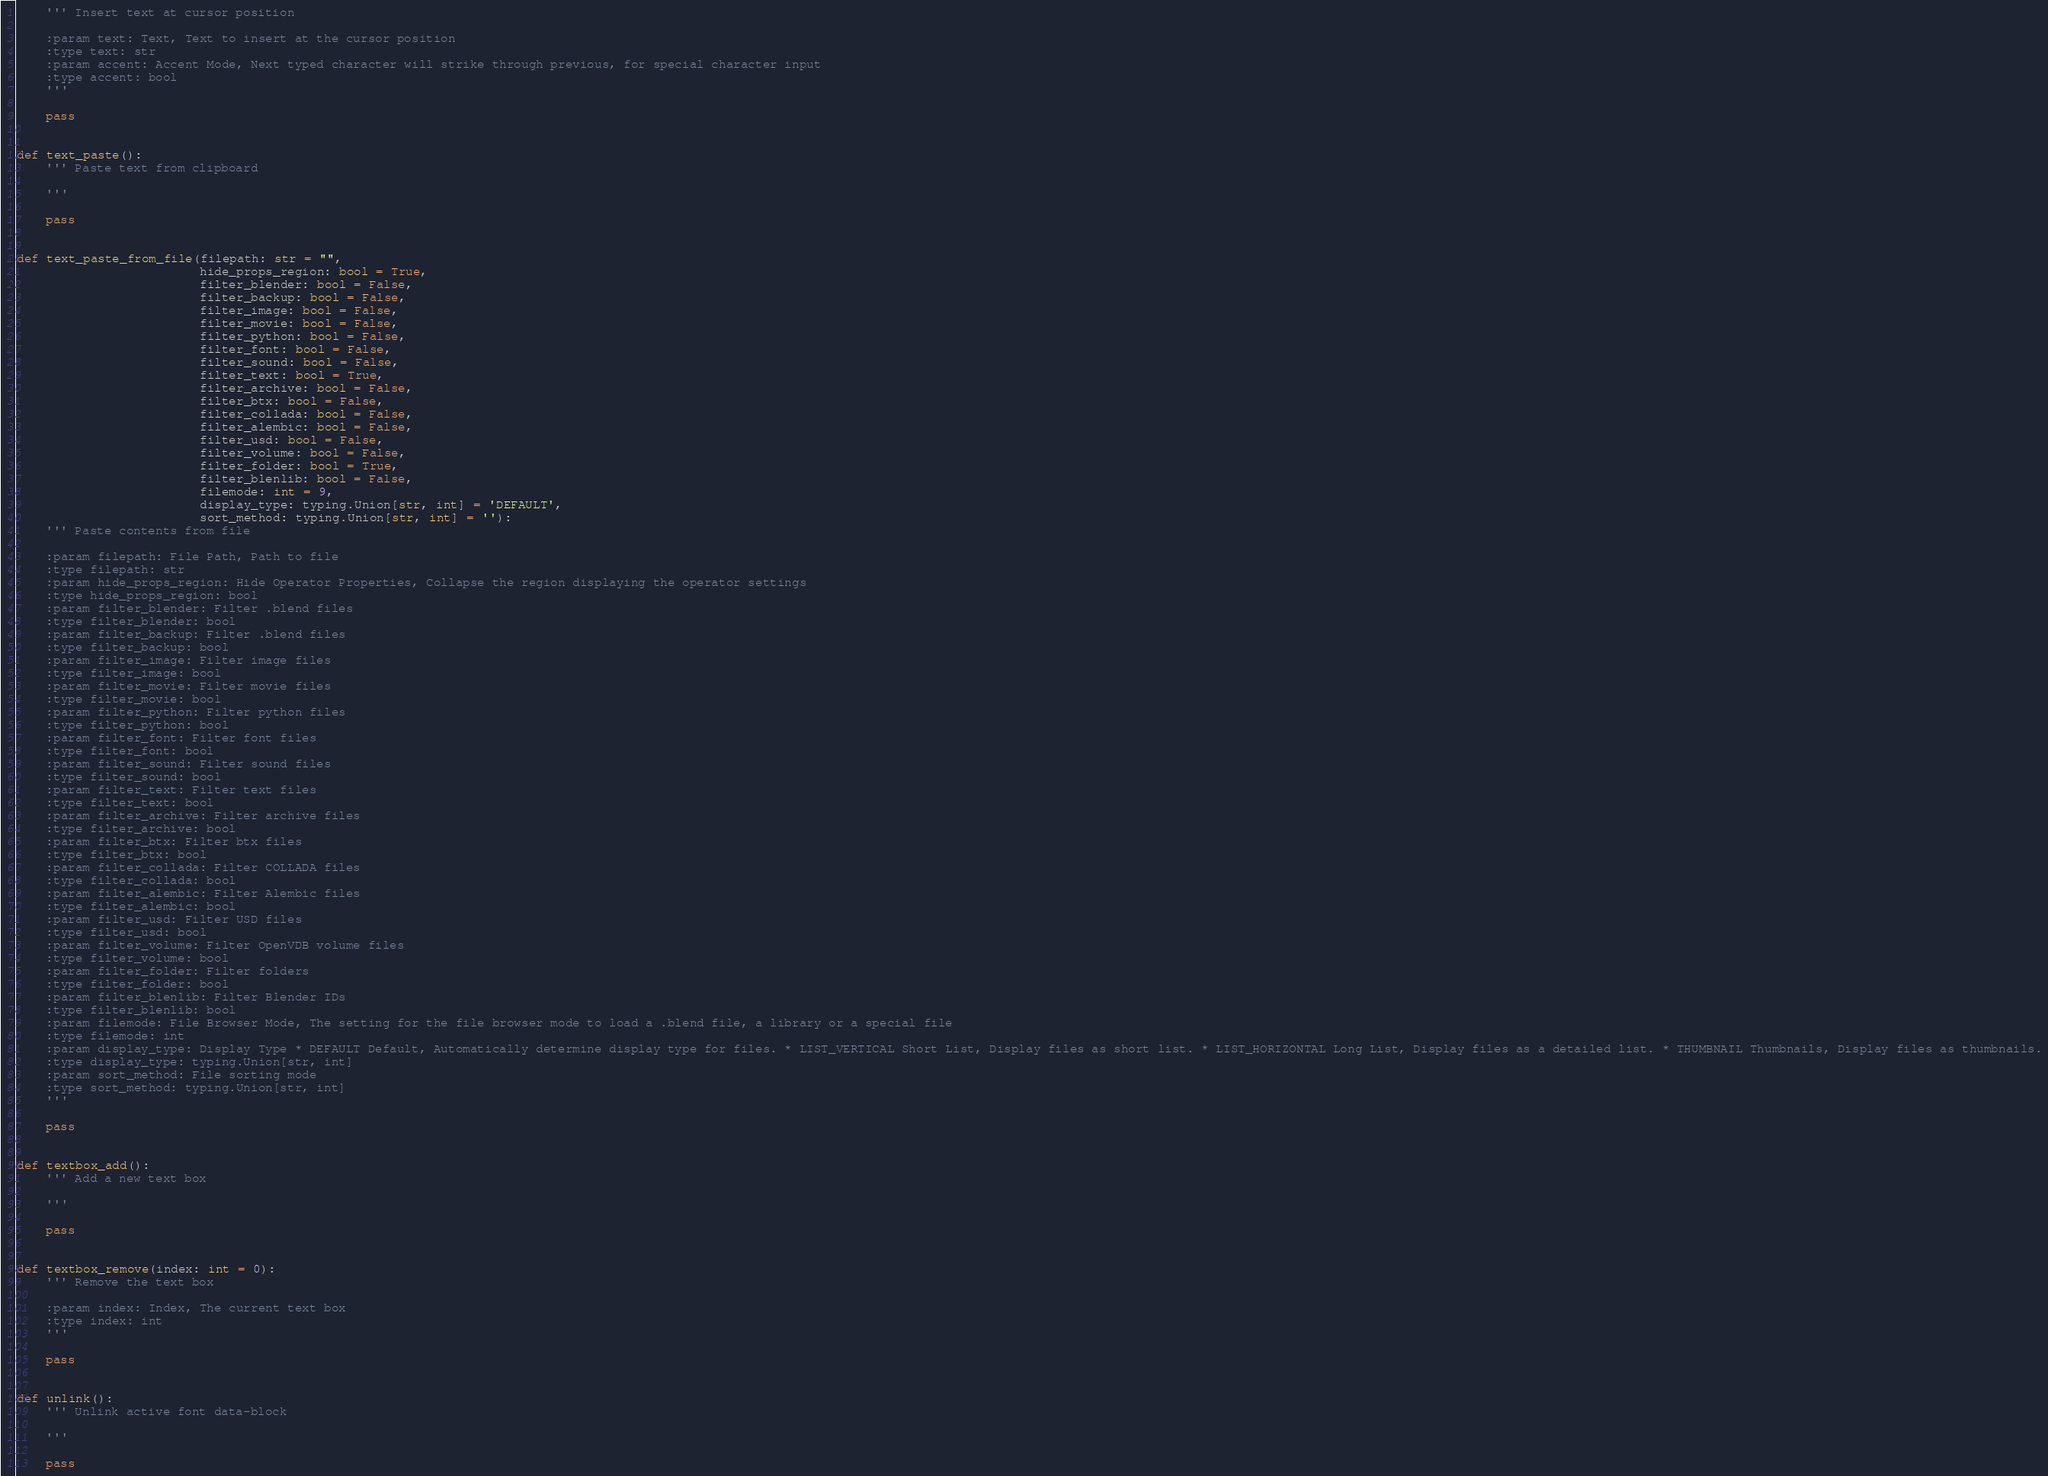<code> <loc_0><loc_0><loc_500><loc_500><_Python_>    ''' Insert text at cursor position

    :param text: Text, Text to insert at the cursor position
    :type text: str
    :param accent: Accent Mode, Next typed character will strike through previous, for special character input
    :type accent: bool
    '''

    pass


def text_paste():
    ''' Paste text from clipboard

    '''

    pass


def text_paste_from_file(filepath: str = "",
                         hide_props_region: bool = True,
                         filter_blender: bool = False,
                         filter_backup: bool = False,
                         filter_image: bool = False,
                         filter_movie: bool = False,
                         filter_python: bool = False,
                         filter_font: bool = False,
                         filter_sound: bool = False,
                         filter_text: bool = True,
                         filter_archive: bool = False,
                         filter_btx: bool = False,
                         filter_collada: bool = False,
                         filter_alembic: bool = False,
                         filter_usd: bool = False,
                         filter_volume: bool = False,
                         filter_folder: bool = True,
                         filter_blenlib: bool = False,
                         filemode: int = 9,
                         display_type: typing.Union[str, int] = 'DEFAULT',
                         sort_method: typing.Union[str, int] = ''):
    ''' Paste contents from file

    :param filepath: File Path, Path to file
    :type filepath: str
    :param hide_props_region: Hide Operator Properties, Collapse the region displaying the operator settings
    :type hide_props_region: bool
    :param filter_blender: Filter .blend files
    :type filter_blender: bool
    :param filter_backup: Filter .blend files
    :type filter_backup: bool
    :param filter_image: Filter image files
    :type filter_image: bool
    :param filter_movie: Filter movie files
    :type filter_movie: bool
    :param filter_python: Filter python files
    :type filter_python: bool
    :param filter_font: Filter font files
    :type filter_font: bool
    :param filter_sound: Filter sound files
    :type filter_sound: bool
    :param filter_text: Filter text files
    :type filter_text: bool
    :param filter_archive: Filter archive files
    :type filter_archive: bool
    :param filter_btx: Filter btx files
    :type filter_btx: bool
    :param filter_collada: Filter COLLADA files
    :type filter_collada: bool
    :param filter_alembic: Filter Alembic files
    :type filter_alembic: bool
    :param filter_usd: Filter USD files
    :type filter_usd: bool
    :param filter_volume: Filter OpenVDB volume files
    :type filter_volume: bool
    :param filter_folder: Filter folders
    :type filter_folder: bool
    :param filter_blenlib: Filter Blender IDs
    :type filter_blenlib: bool
    :param filemode: File Browser Mode, The setting for the file browser mode to load a .blend file, a library or a special file
    :type filemode: int
    :param display_type: Display Type * DEFAULT Default, Automatically determine display type for files. * LIST_VERTICAL Short List, Display files as short list. * LIST_HORIZONTAL Long List, Display files as a detailed list. * THUMBNAIL Thumbnails, Display files as thumbnails.
    :type display_type: typing.Union[str, int]
    :param sort_method: File sorting mode
    :type sort_method: typing.Union[str, int]
    '''

    pass


def textbox_add():
    ''' Add a new text box

    '''

    pass


def textbox_remove(index: int = 0):
    ''' Remove the text box

    :param index: Index, The current text box
    :type index: int
    '''

    pass


def unlink():
    ''' Unlink active font data-block

    '''

    pass
</code> 